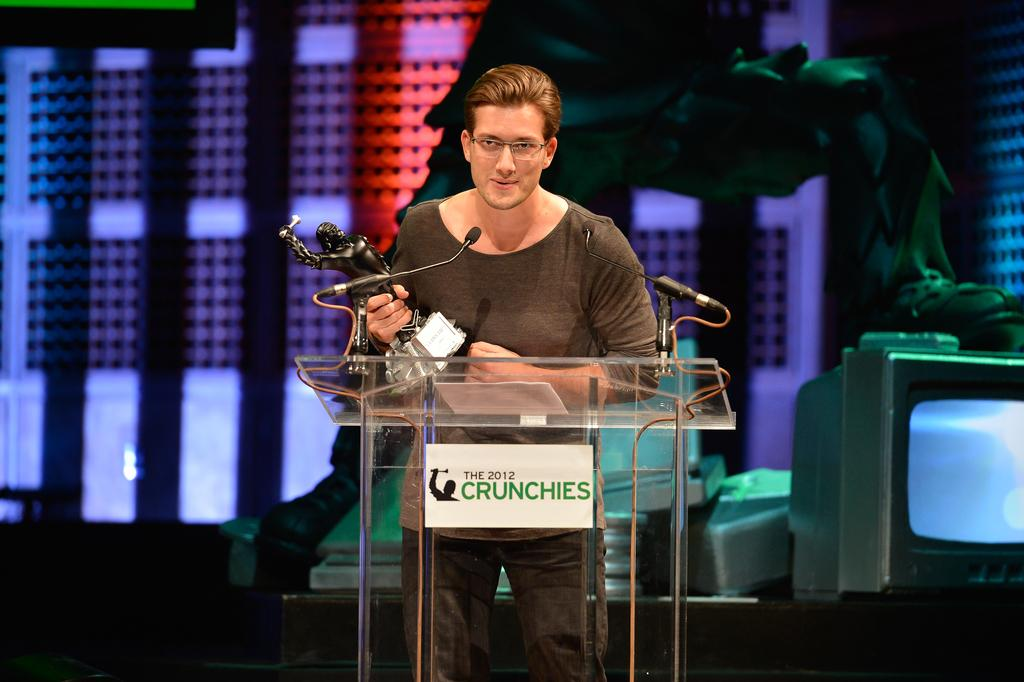<image>
Render a clear and concise summary of the photo. A man is accepting an award at The 2012 Crunchies. 